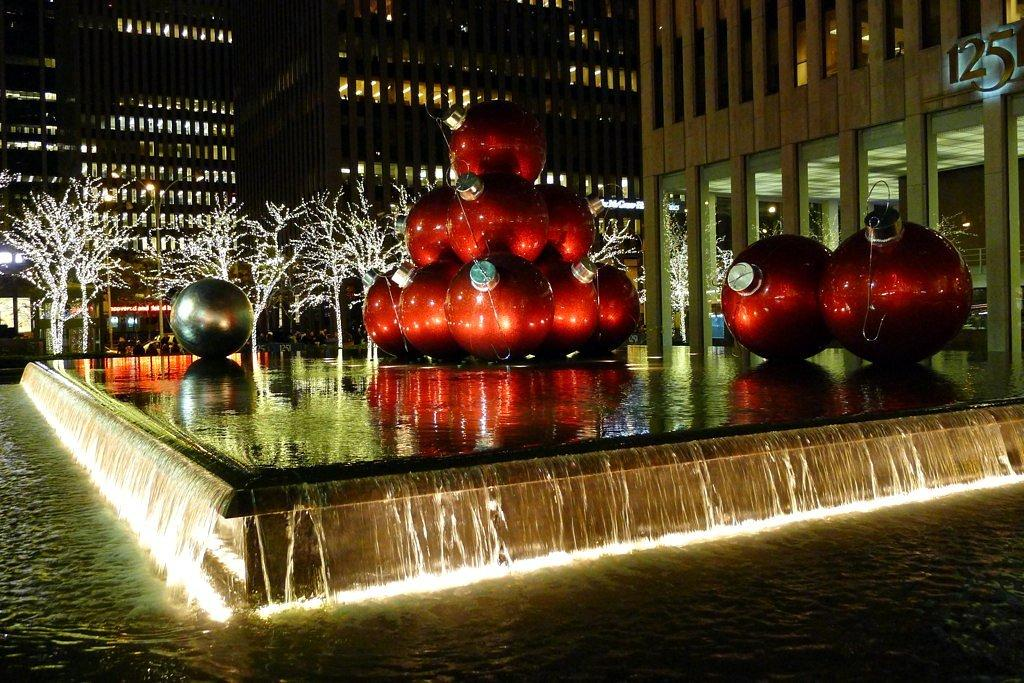What is visible in the image that is not a building or a tree? There is water visible in the image, as well as decorations and light poles. What can be seen on the buildings in the image? The buildings have windows. What type of vegetation is present in the image? There are trees in the image. What type of cherry is hanging from the light poles in the image? There are no cherries present in the image, and the light poles do not have any hanging fruit. 